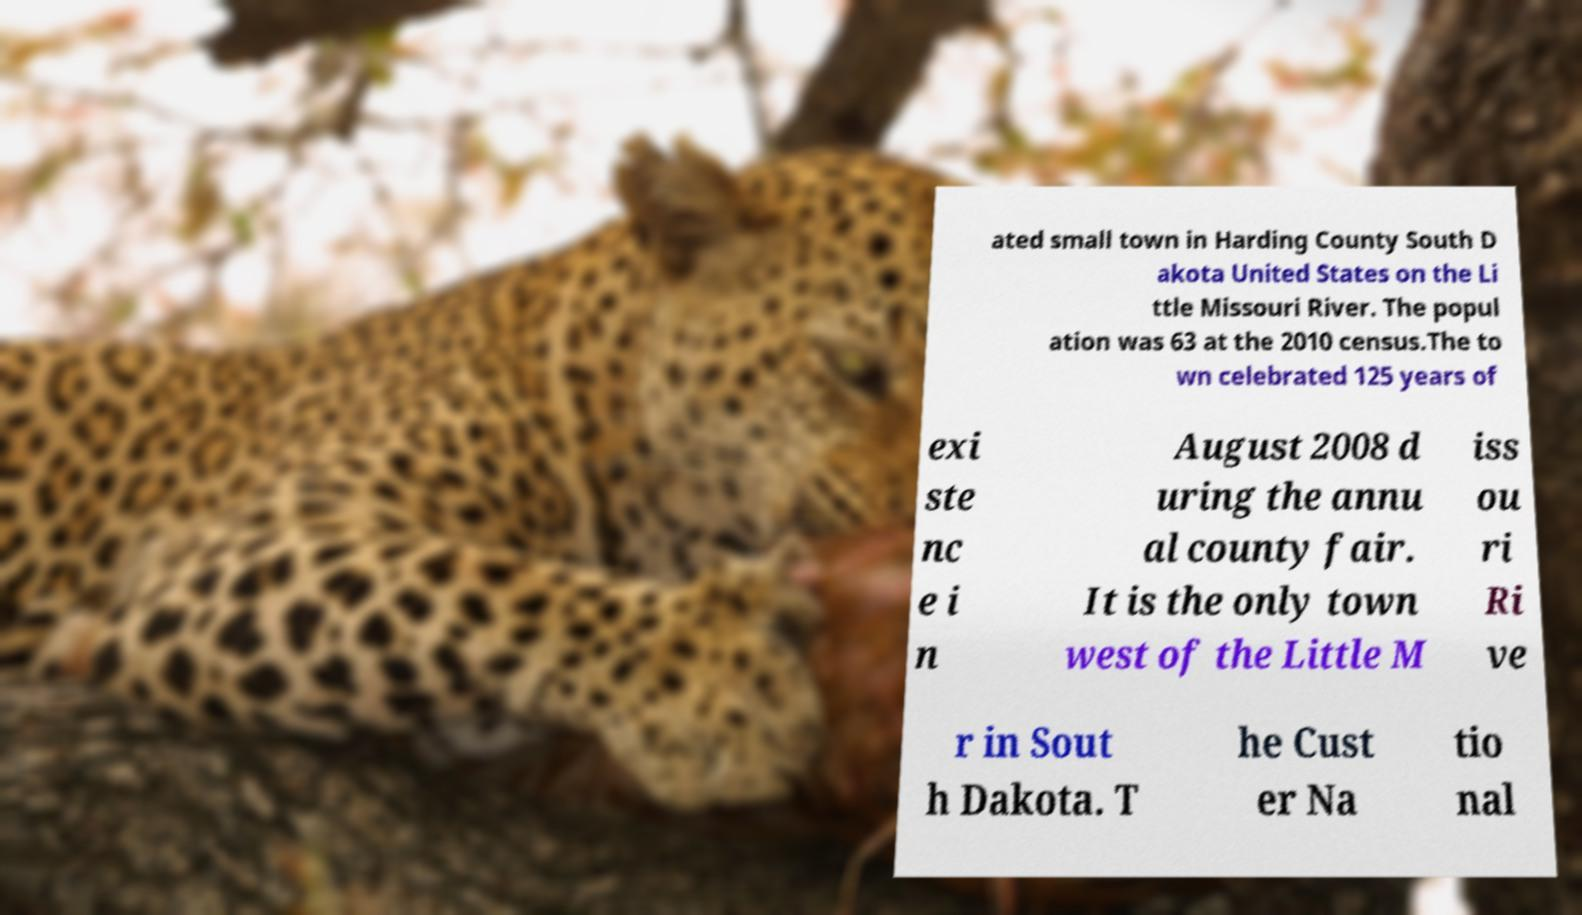There's text embedded in this image that I need extracted. Can you transcribe it verbatim? ated small town in Harding County South D akota United States on the Li ttle Missouri River. The popul ation was 63 at the 2010 census.The to wn celebrated 125 years of exi ste nc e i n August 2008 d uring the annu al county fair. It is the only town west of the Little M iss ou ri Ri ve r in Sout h Dakota. T he Cust er Na tio nal 